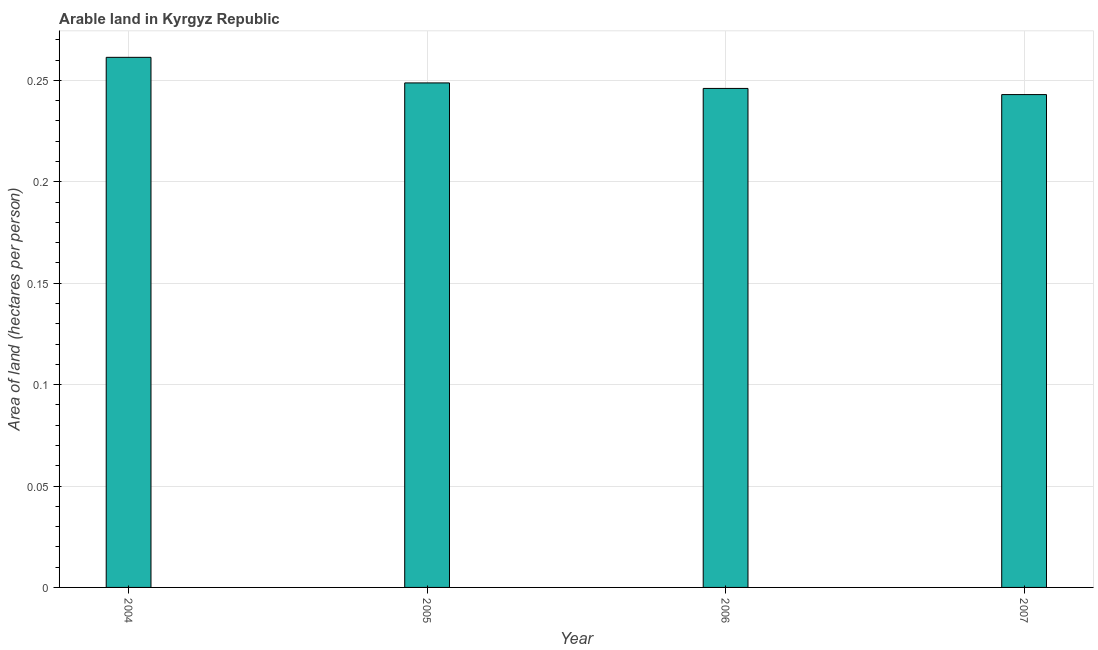What is the title of the graph?
Your response must be concise. Arable land in Kyrgyz Republic. What is the label or title of the X-axis?
Your response must be concise. Year. What is the label or title of the Y-axis?
Your response must be concise. Area of land (hectares per person). What is the area of arable land in 2006?
Make the answer very short. 0.25. Across all years, what is the maximum area of arable land?
Your answer should be compact. 0.26. Across all years, what is the minimum area of arable land?
Provide a succinct answer. 0.24. In which year was the area of arable land maximum?
Your answer should be compact. 2004. What is the sum of the area of arable land?
Provide a succinct answer. 1. What is the difference between the area of arable land in 2004 and 2006?
Offer a very short reply. 0.01. What is the average area of arable land per year?
Make the answer very short. 0.25. What is the median area of arable land?
Your answer should be compact. 0.25. What is the ratio of the area of arable land in 2006 to that in 2007?
Offer a terse response. 1.01. What is the difference between the highest and the second highest area of arable land?
Your response must be concise. 0.01. What is the difference between the highest and the lowest area of arable land?
Keep it short and to the point. 0.02. How many bars are there?
Offer a very short reply. 4. Are all the bars in the graph horizontal?
Your response must be concise. No. How many years are there in the graph?
Offer a terse response. 4. What is the Area of land (hectares per person) in 2004?
Offer a terse response. 0.26. What is the Area of land (hectares per person) of 2005?
Your response must be concise. 0.25. What is the Area of land (hectares per person) in 2006?
Ensure brevity in your answer.  0.25. What is the Area of land (hectares per person) of 2007?
Your answer should be very brief. 0.24. What is the difference between the Area of land (hectares per person) in 2004 and 2005?
Give a very brief answer. 0.01. What is the difference between the Area of land (hectares per person) in 2004 and 2006?
Provide a short and direct response. 0.02. What is the difference between the Area of land (hectares per person) in 2004 and 2007?
Offer a terse response. 0.02. What is the difference between the Area of land (hectares per person) in 2005 and 2006?
Give a very brief answer. 0. What is the difference between the Area of land (hectares per person) in 2005 and 2007?
Provide a short and direct response. 0.01. What is the difference between the Area of land (hectares per person) in 2006 and 2007?
Ensure brevity in your answer.  0. What is the ratio of the Area of land (hectares per person) in 2004 to that in 2005?
Keep it short and to the point. 1.05. What is the ratio of the Area of land (hectares per person) in 2004 to that in 2006?
Offer a very short reply. 1.06. What is the ratio of the Area of land (hectares per person) in 2004 to that in 2007?
Give a very brief answer. 1.08. What is the ratio of the Area of land (hectares per person) in 2005 to that in 2007?
Keep it short and to the point. 1.02. 